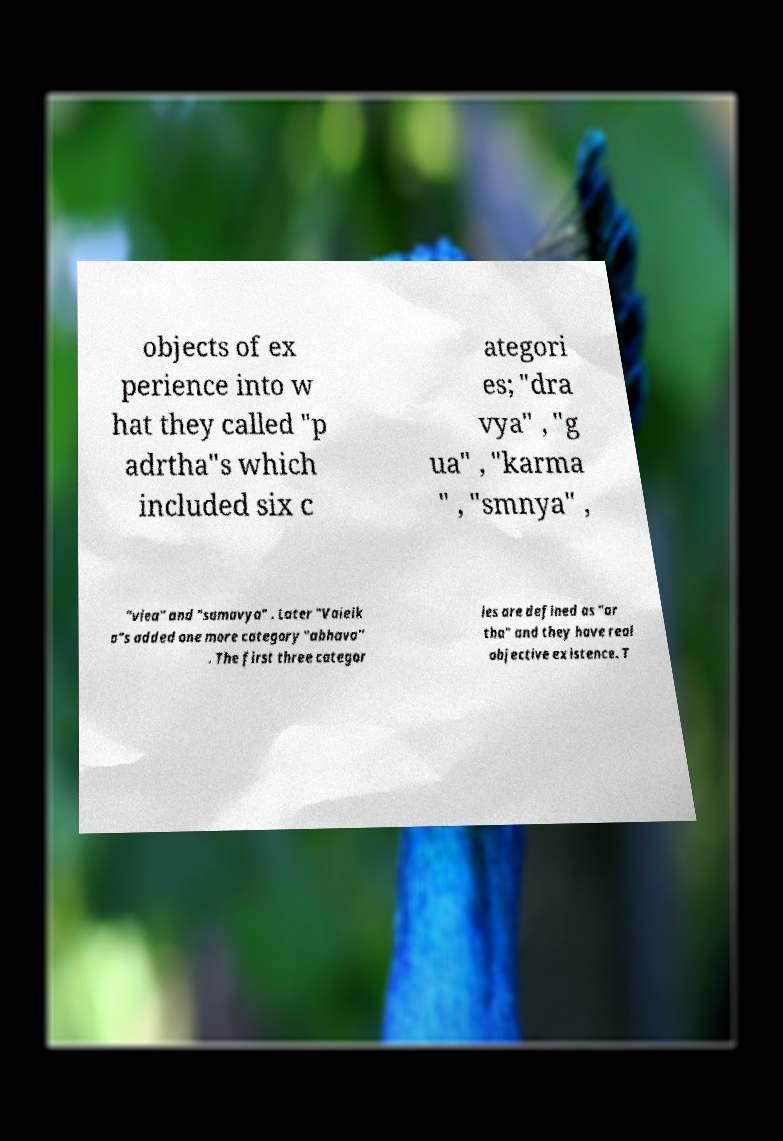Can you read and provide the text displayed in the image?This photo seems to have some interesting text. Can you extract and type it out for me? objects of ex perience into w hat they called "p adrtha"s which included six c ategori es; "dra vya" , "g ua" , "karma " , "smnya" , "viea" and "samavya" . Later "Vaieik a"s added one more category "abhava" . The first three categor ies are defined as "ar tha" and they have real objective existence. T 